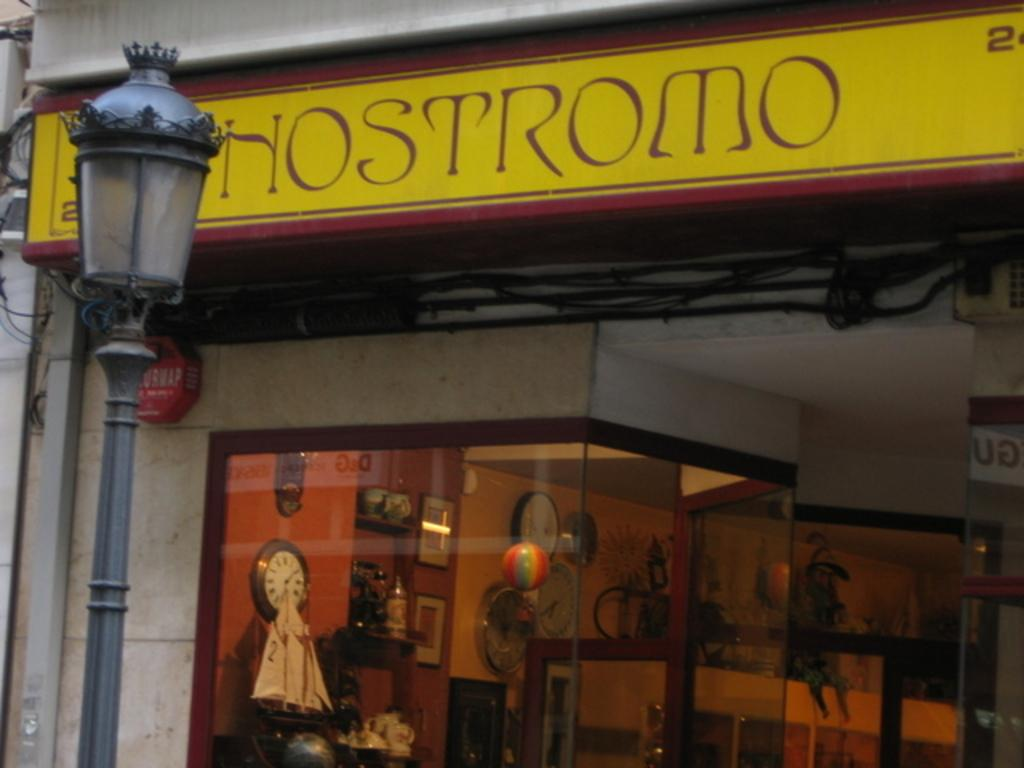Provide a one-sentence caption for the provided image. Hostromo building with multiple clocks on the inside. 